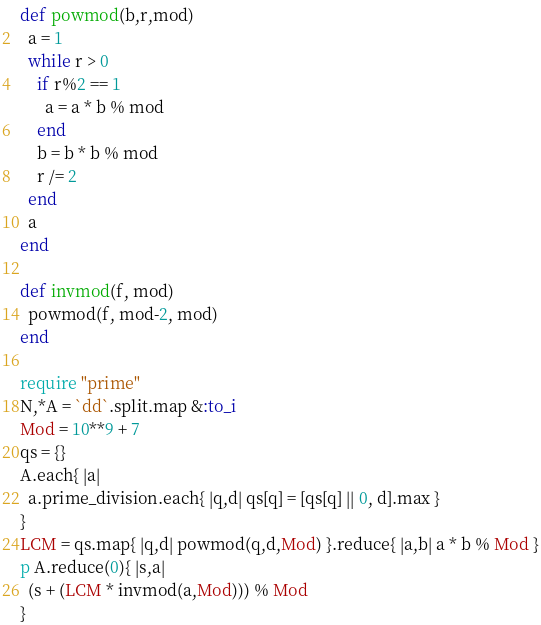Convert code to text. <code><loc_0><loc_0><loc_500><loc_500><_Ruby_>def powmod(b,r,mod)
  a = 1
  while r > 0
    if r%2 == 1
      a = a * b % mod
    end
    b = b * b % mod
    r /= 2
  end
  a
end

def invmod(f, mod)
  powmod(f, mod-2, mod)
end

require "prime"
N,*A = `dd`.split.map &:to_i
Mod = 10**9 + 7
qs = {}
A.each{ |a|
  a.prime_division.each{ |q,d| qs[q] = [qs[q] || 0, d].max }
}
LCM = qs.map{ |q,d| powmod(q,d,Mod) }.reduce{ |a,b| a * b % Mod }
p A.reduce(0){ |s,a|
  (s + (LCM * invmod(a,Mod))) % Mod
}</code> 